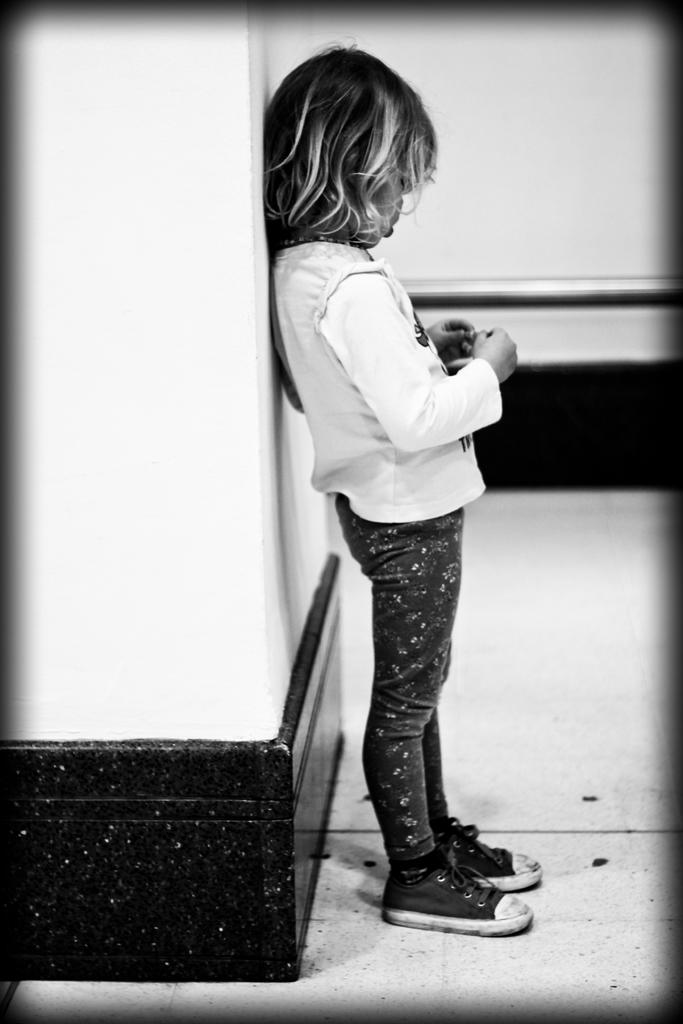What is the main subject of the image? There is a girl standing in the image. What can be seen behind the girl? There is a wall visible behind the girl. What type of record is the girl holding in the image? There is no record present in the image; the girl is simply standing. 